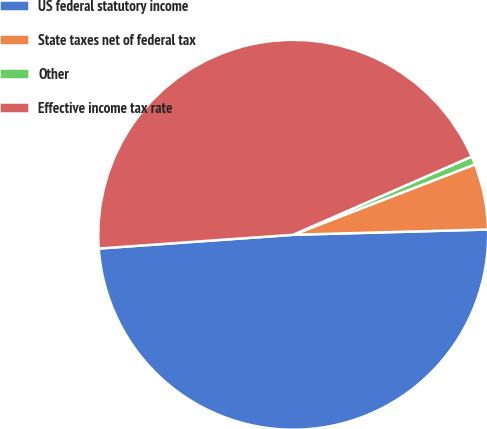Convert chart to OTSL. <chart><loc_0><loc_0><loc_500><loc_500><pie_chart><fcel>US federal statutory income<fcel>State taxes net of federal tax<fcel>Other<fcel>Effective income tax rate<nl><fcel>49.31%<fcel>5.45%<fcel>0.69%<fcel>44.55%<nl></chart> 